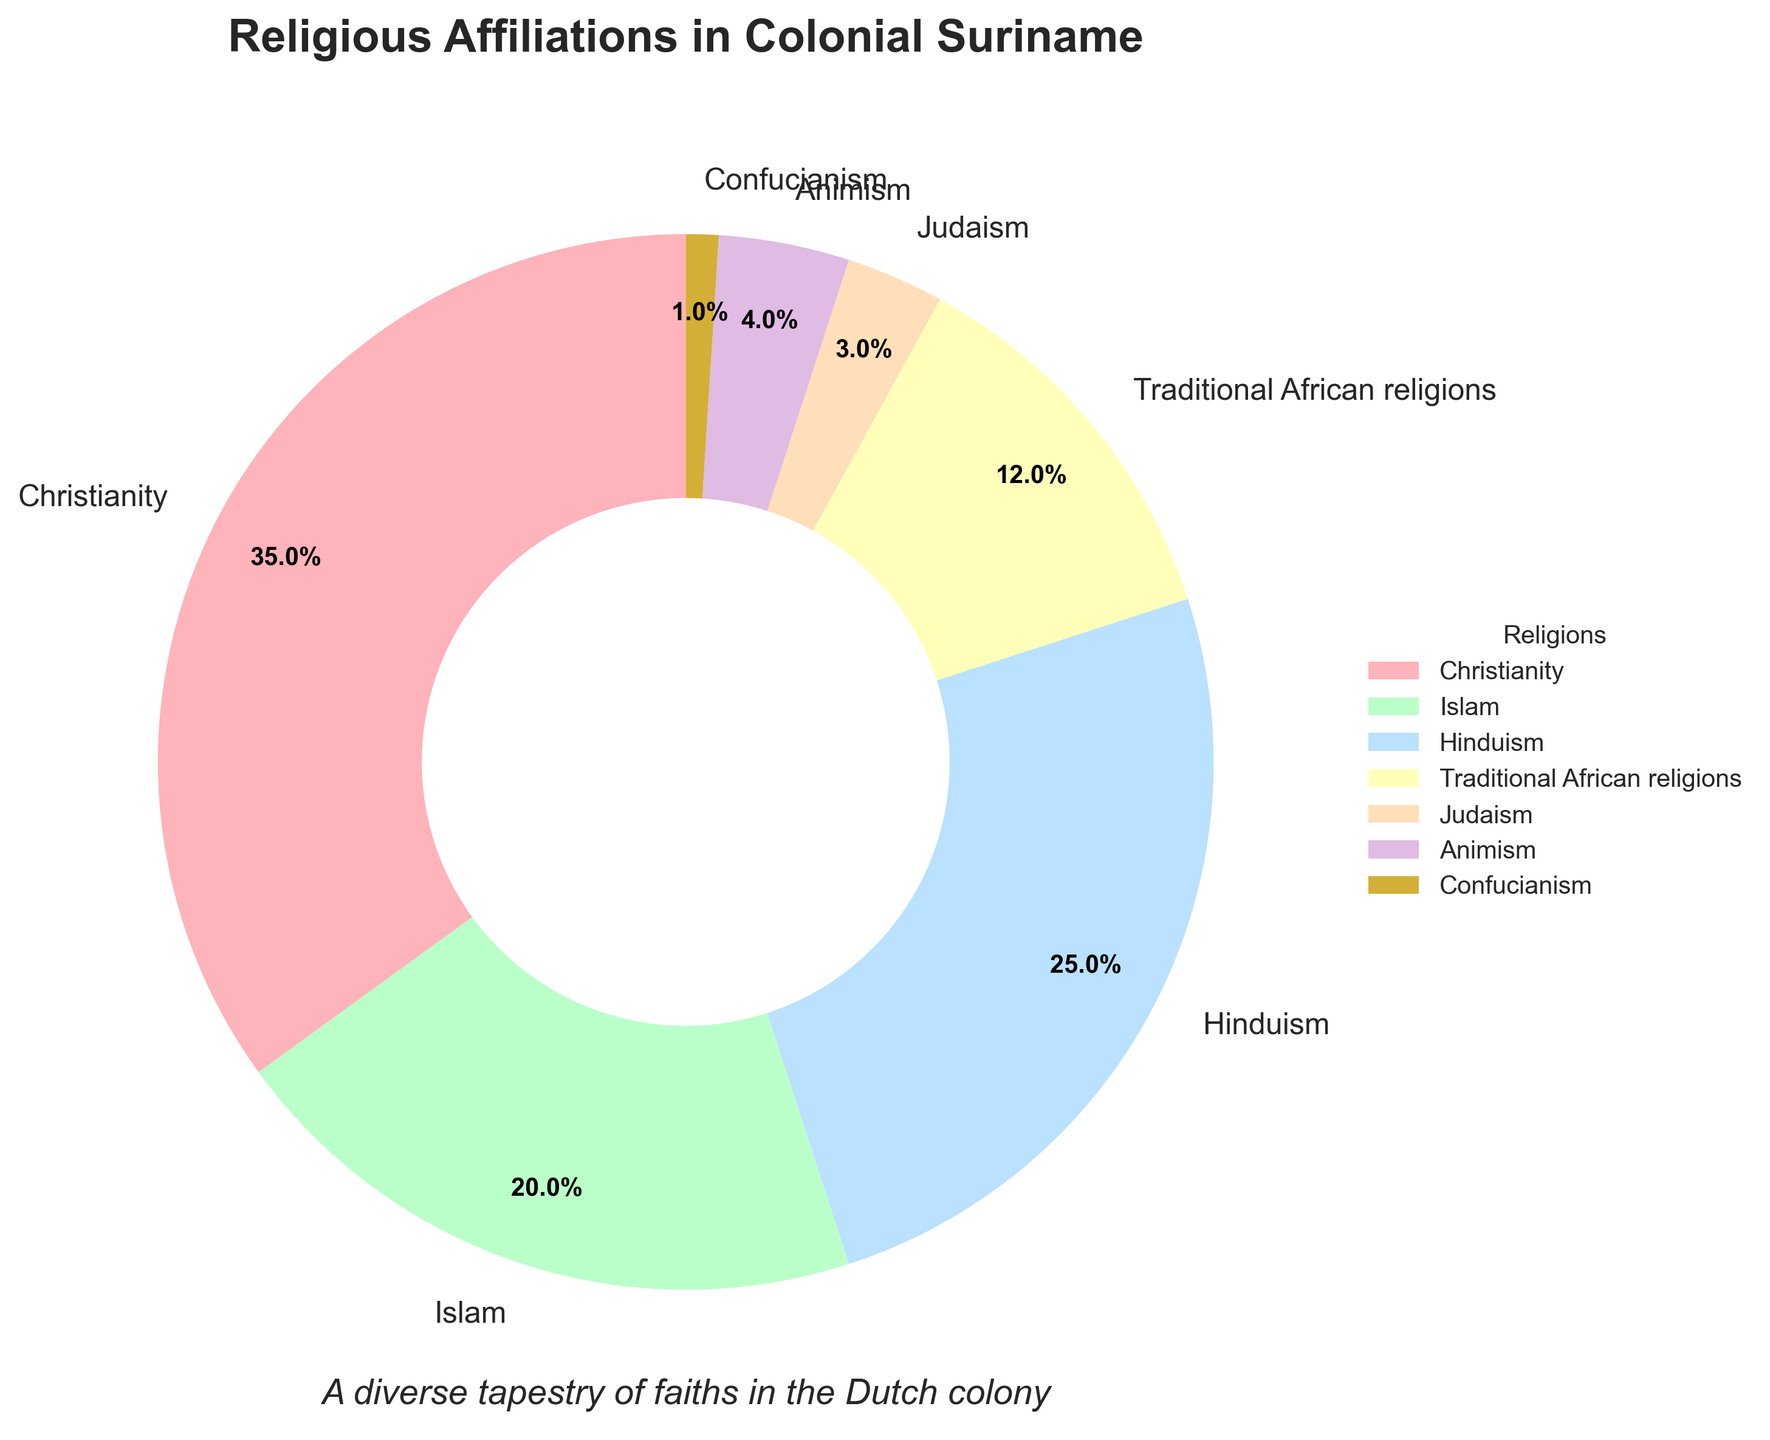What's the most common religious affiliation in colonial Suriname? The chart shows the percentages of different religious affiliations. Christianity has the highest percentage at 35%, making it the most common.
Answer: Christianity Which religious affiliation has the smallest representation in colonial Suriname? The pie chart displays various religious affiliations and their respective percentages. Confucianism has the smallest slice, indicating a 1% representation.
Answer: Confucianism How much larger is the percentage of Islam compared to Judaism? From the chart, Islam is 20% and Judaism is 3%. To find the difference, subtract Judaism's percentage from Islam's: 20% - 3% = 17%.
Answer: 17% What combined percentage do Traditional African religions and Animism account for? The pie chart shows Traditional African religions at 12% and Animism at 4%. Adding these together: 12% + 4% = 16%.
Answer: 16% Which two religious affiliations together are closest to a third of the total population? A third of 100% is approximately 33.3%. Hinduism at 25% and Judaism at 3% combined make 28%, which is closest to 33.3% when compared to other combinations.
Answer: Hinduism and Judaism Is the percentage of those practicing Traditional African religions greater than those practicing Hinduism? From the chart, Traditional African religions have a 12% representation, while Hinduism has a 25% representation. Clearly, 12% is not greater than 25%.
Answer: No How does the representation of Christianity compare to that of Islam and Hinduism combined? Christianity is at 35%. Islam and Hinduism together sum to 20% + 25% = 45%. Hence, Christianity is less than the sum of Islam and Hinduism.
Answer: Christianity is less What is the second most common religious affiliation? After Christianity at 35%, Hinduism is the next largest percentage at 25%, making it the second most common.
Answer: Hinduism What can be inferred about the religious diversity in colonial Suriname? The pie chart shows multiple religious affiliations with none dominating overwhelmingly, indicating significant religious diversity.
Answer: Significant religious diversity 